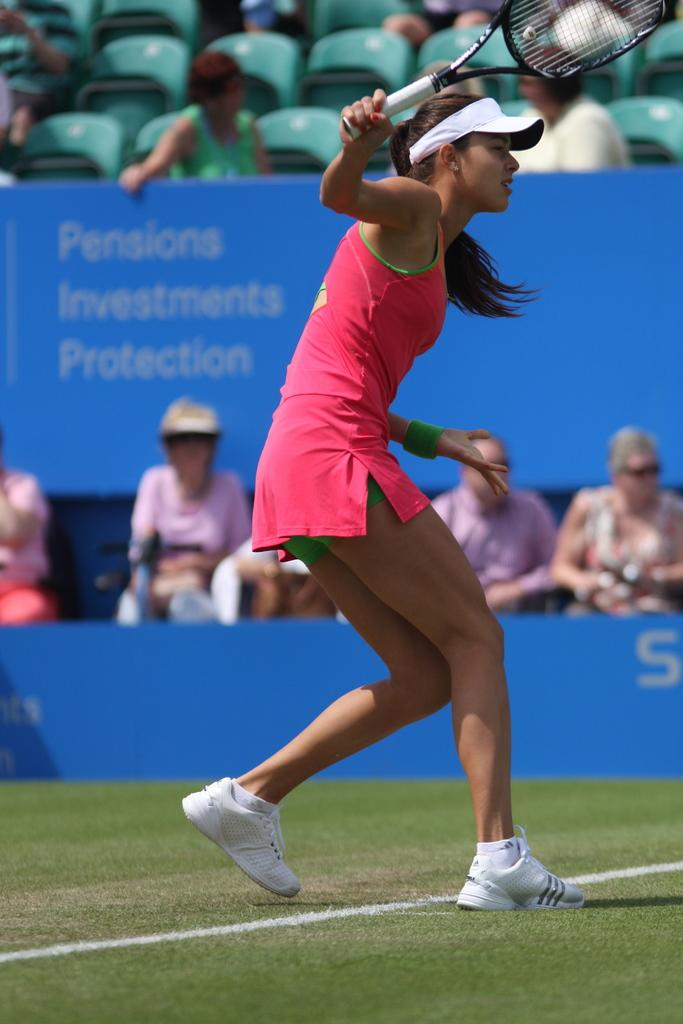What activity is the girl in the image engaged in? The girl is playing tennis in the image. What is the surface of the tennis court made of? The tennis court is made of grass. Are there any spectators in the image? Yes, people are watching the girl play tennis. What type of wood is used to make the sack that the girl is carrying in the image? There is no sack present in the image, and therefore no wood or any other material used to make it. 